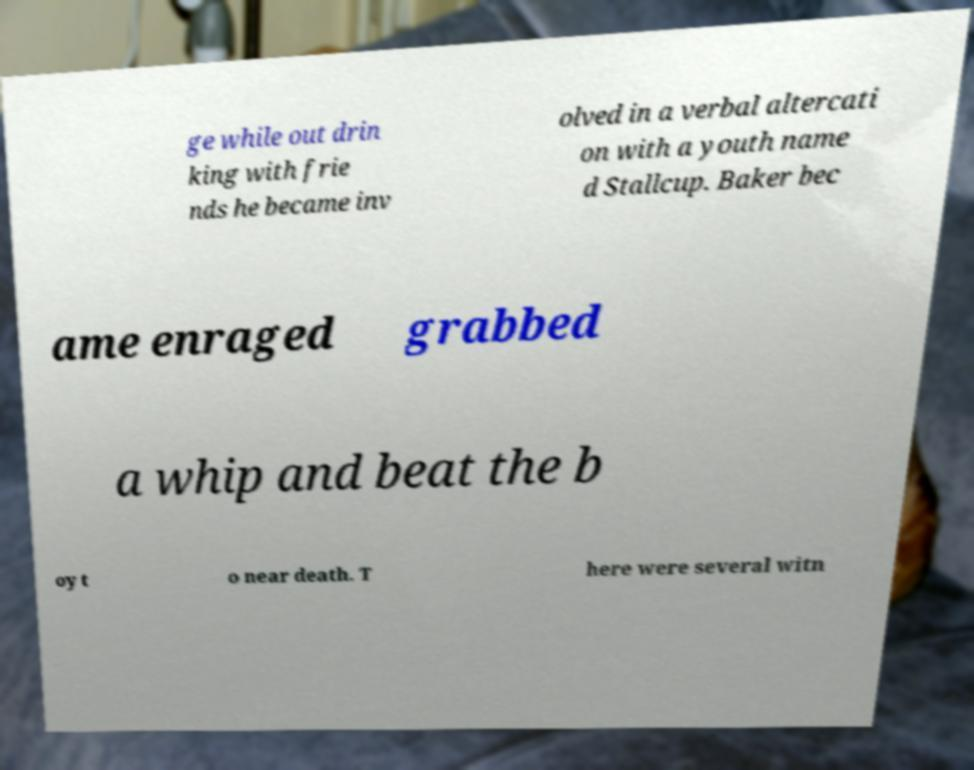Can you accurately transcribe the text from the provided image for me? ge while out drin king with frie nds he became inv olved in a verbal altercati on with a youth name d Stallcup. Baker bec ame enraged grabbed a whip and beat the b oy t o near death. T here were several witn 